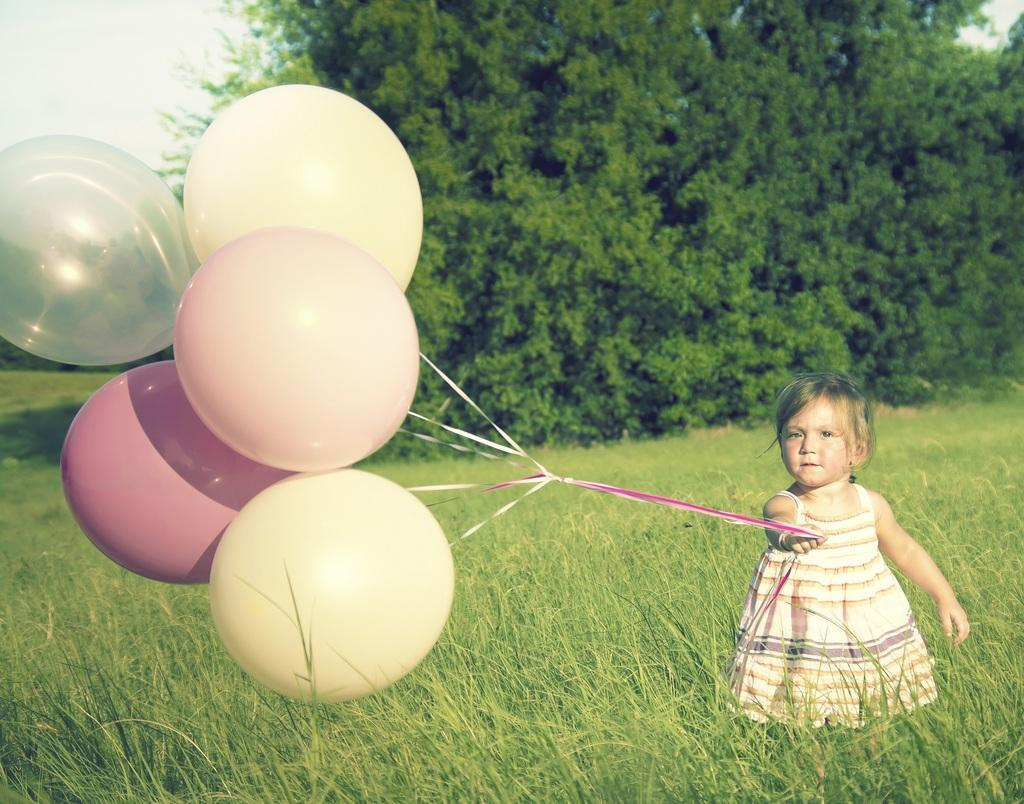What is the main subject of the picture? The main subject of the picture is a kid. What is the kid holding in her hand? The kid is holding balloons in her hand. What type of surface is visible at the bottom of the picture? There is grass on the ground in the bottom of the picture. What can be seen in the background of the picture? There are trees in the background of the picture. What type of power source can be seen in the image? There is no power source visible in the image. What button is the kid pressing in the image? The kid is not pressing any button in the image; she is holding balloons. 